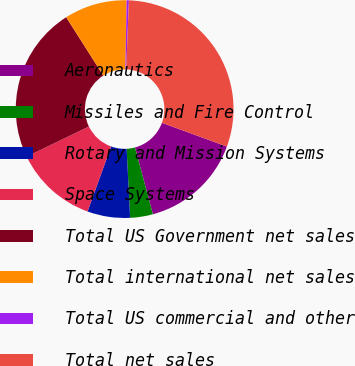<chart> <loc_0><loc_0><loc_500><loc_500><pie_chart><fcel>Aeronautics<fcel>Missiles and Fire Control<fcel>Rotary and Mission Systems<fcel>Space Systems<fcel>Total US Government net sales<fcel>Total international net sales<fcel>Total US commercial and other<fcel>Total net sales<nl><fcel>15.23%<fcel>3.38%<fcel>6.34%<fcel>12.27%<fcel>23.17%<fcel>9.31%<fcel>0.33%<fcel>29.96%<nl></chart> 